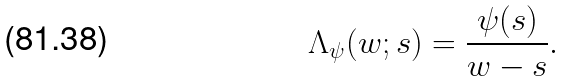Convert formula to latex. <formula><loc_0><loc_0><loc_500><loc_500>\Lambda _ { \psi } ( w ; s ) = \frac { \psi ( s ) } { w - s } .</formula> 